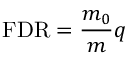Convert formula to latex. <formula><loc_0><loc_0><loc_500><loc_500>F D R = { \frac { m _ { 0 } } { m } } q</formula> 